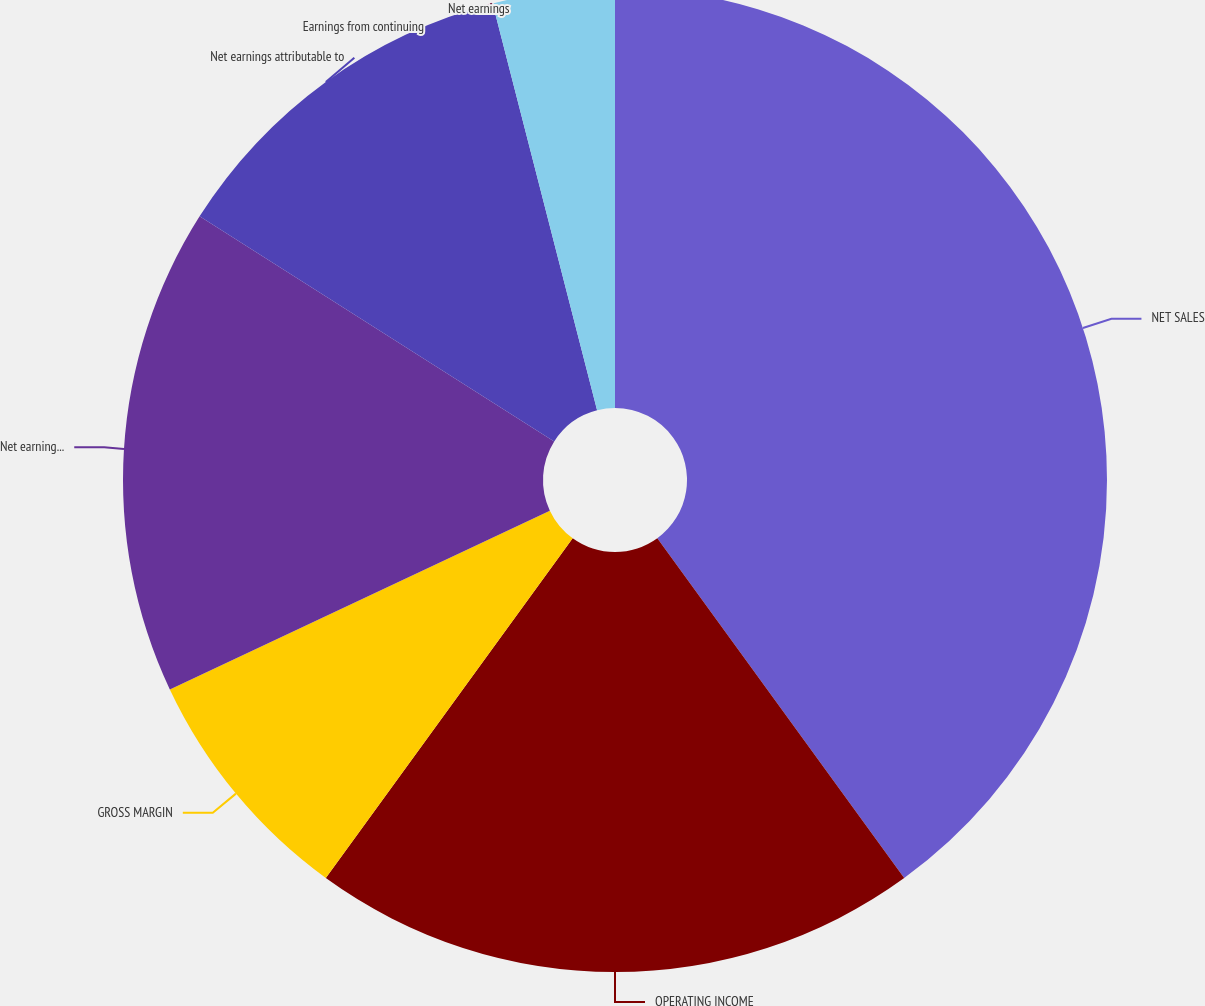<chart> <loc_0><loc_0><loc_500><loc_500><pie_chart><fcel>NET SALES<fcel>OPERATING INCOME<fcel>GROSS MARGIN<fcel>Net earnings from continuing<fcel>Net earnings attributable to<fcel>Earnings from continuing<fcel>Net earnings<nl><fcel>40.0%<fcel>20.0%<fcel>8.0%<fcel>16.0%<fcel>12.0%<fcel>0.0%<fcel>4.0%<nl></chart> 